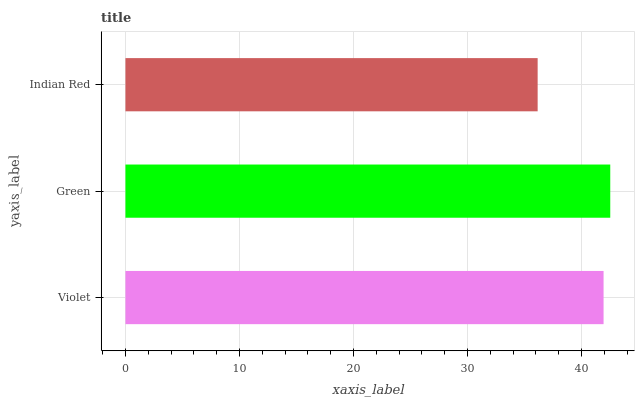Is Indian Red the minimum?
Answer yes or no. Yes. Is Green the maximum?
Answer yes or no. Yes. Is Green the minimum?
Answer yes or no. No. Is Indian Red the maximum?
Answer yes or no. No. Is Green greater than Indian Red?
Answer yes or no. Yes. Is Indian Red less than Green?
Answer yes or no. Yes. Is Indian Red greater than Green?
Answer yes or no. No. Is Green less than Indian Red?
Answer yes or no. No. Is Violet the high median?
Answer yes or no. Yes. Is Violet the low median?
Answer yes or no. Yes. Is Indian Red the high median?
Answer yes or no. No. Is Indian Red the low median?
Answer yes or no. No. 